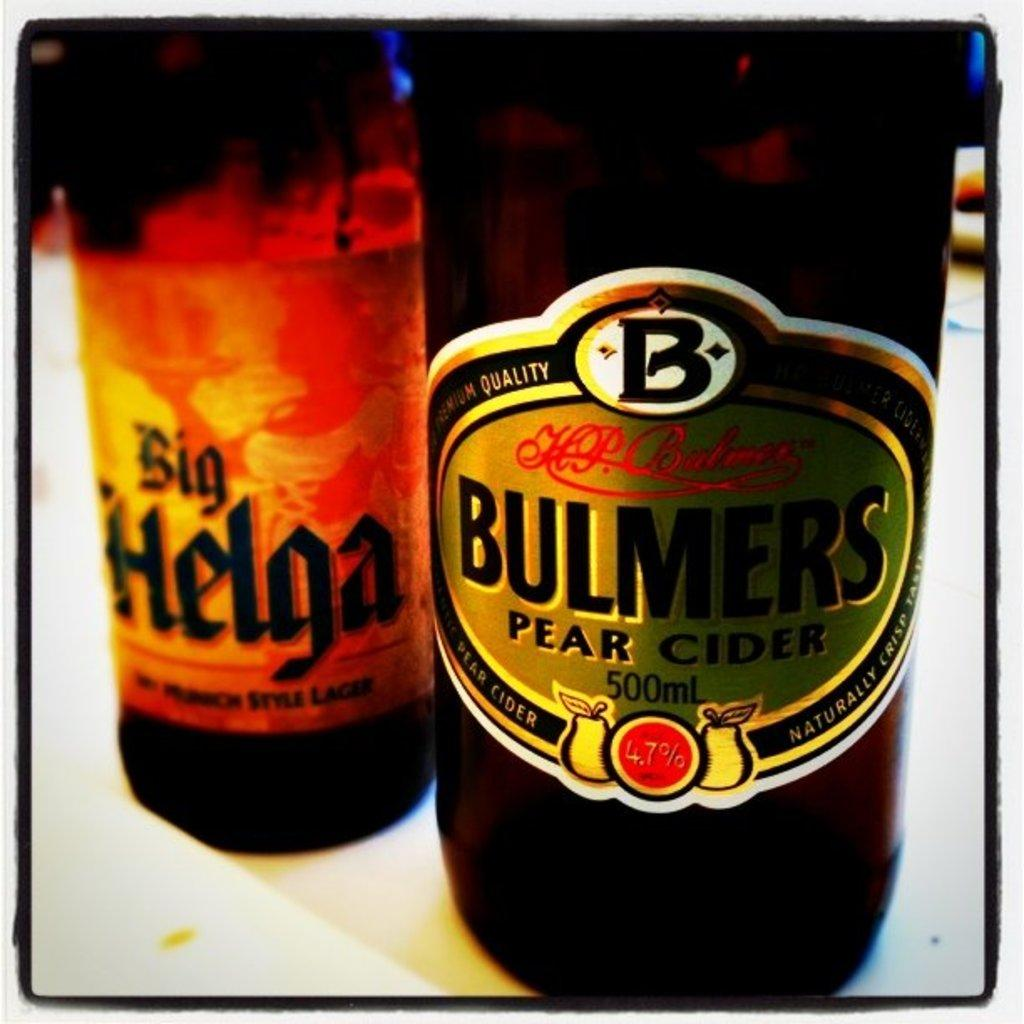<image>
Share a concise interpretation of the image provided. Big Helga has a bright orange and yellow label, while Bulmers Cider is Gold. 